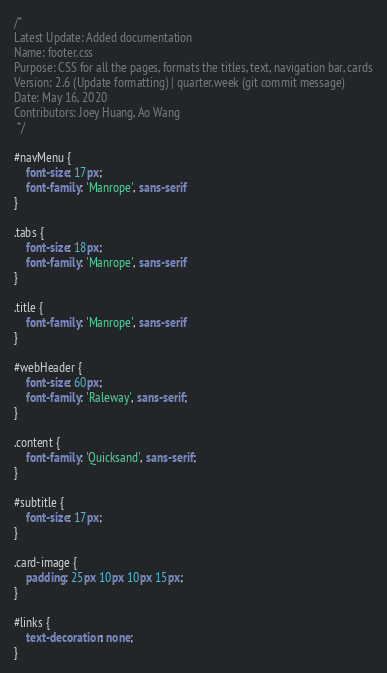<code> <loc_0><loc_0><loc_500><loc_500><_CSS_>/* 
Latest Update: Added documentation 
Name: footer.css
Purpose: CSS for all the pages, formats the titles, text, navigation bar, cards
Version: 2.6 (Update formatting) | quarter.week (git commit message)
Date: May 16, 2020
Contributors: Joey Huang, Ao Wang
 */

#navMenu {
	font-size: 17px;
	font-family: 'Manrope', sans-serif
}

.tabs {
	font-size: 18px;
	font-family: 'Manrope', sans-serif
}

.title {
	font-family: 'Manrope', sans-serif
}

#webHeader {
	font-size: 60px;
	font-family: 'Raleway', sans-serif;
}

.content {
	font-family: 'Quicksand', sans-serif;
}

#subtitle {
	font-size: 17px;
}

.card-image {
	padding: 25px 10px 10px 15px;
}

#links {
	text-decoration: none;
}</code> 